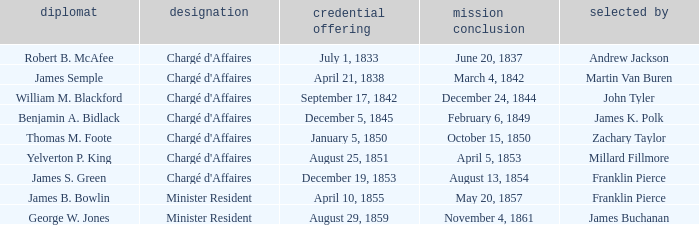What Representative has a Presentation of Credentails of April 10, 1855? James B. Bowlin. 